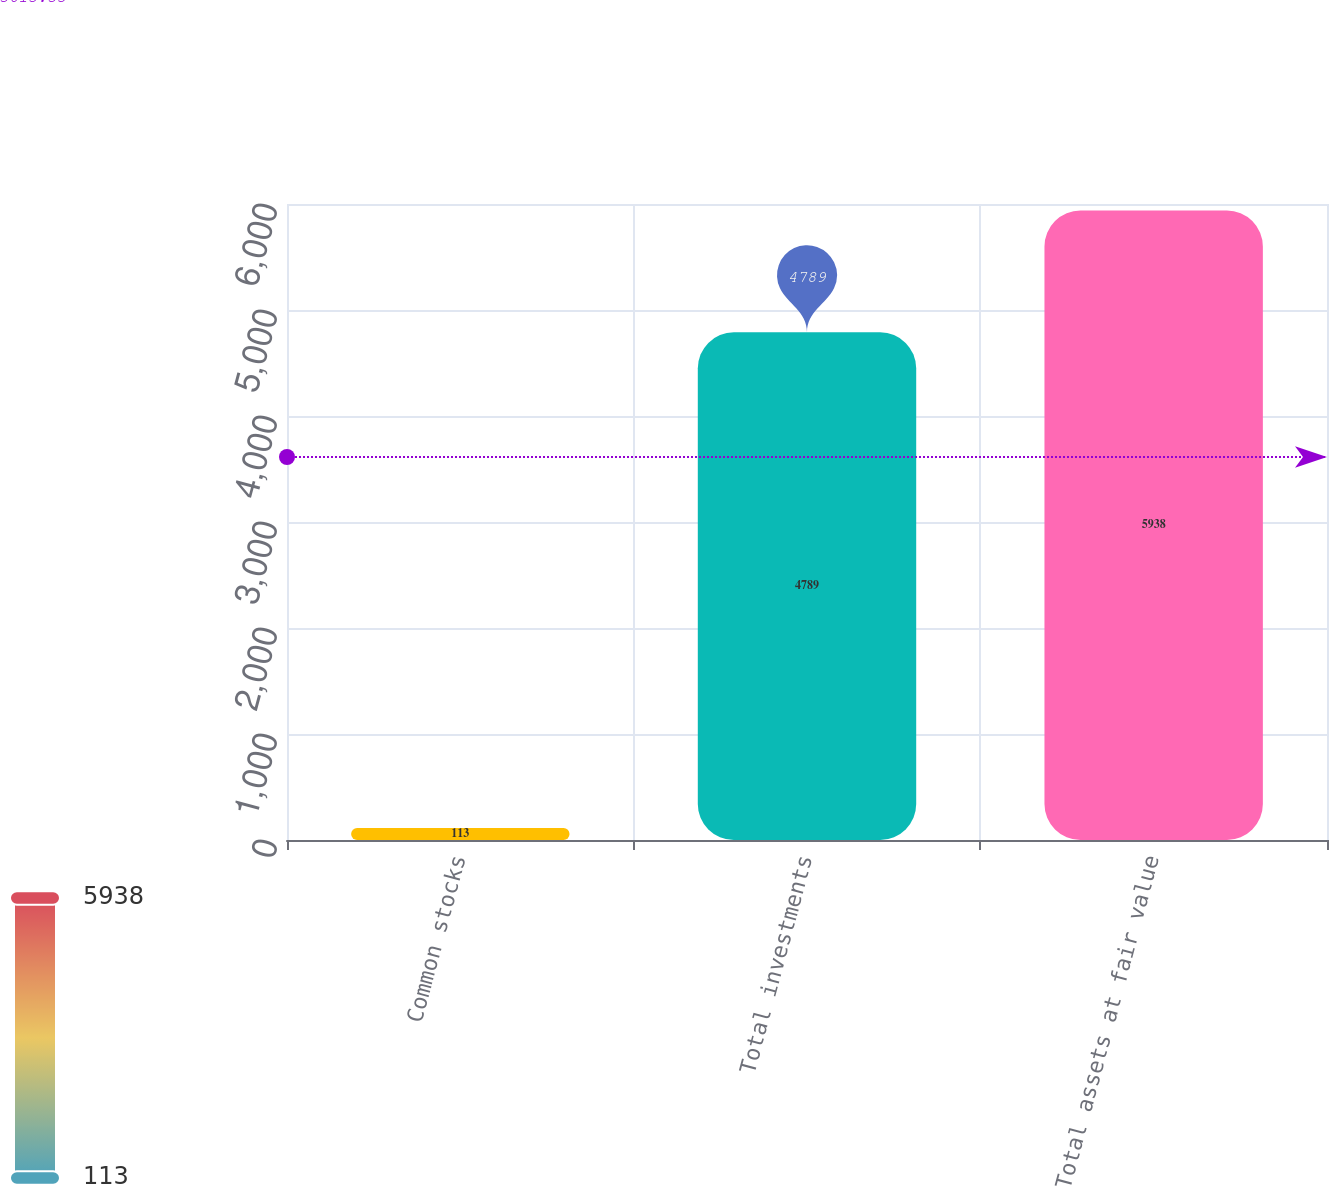<chart> <loc_0><loc_0><loc_500><loc_500><bar_chart><fcel>Common stocks<fcel>Total investments<fcel>Total assets at fair value<nl><fcel>113<fcel>4789<fcel>5938<nl></chart> 